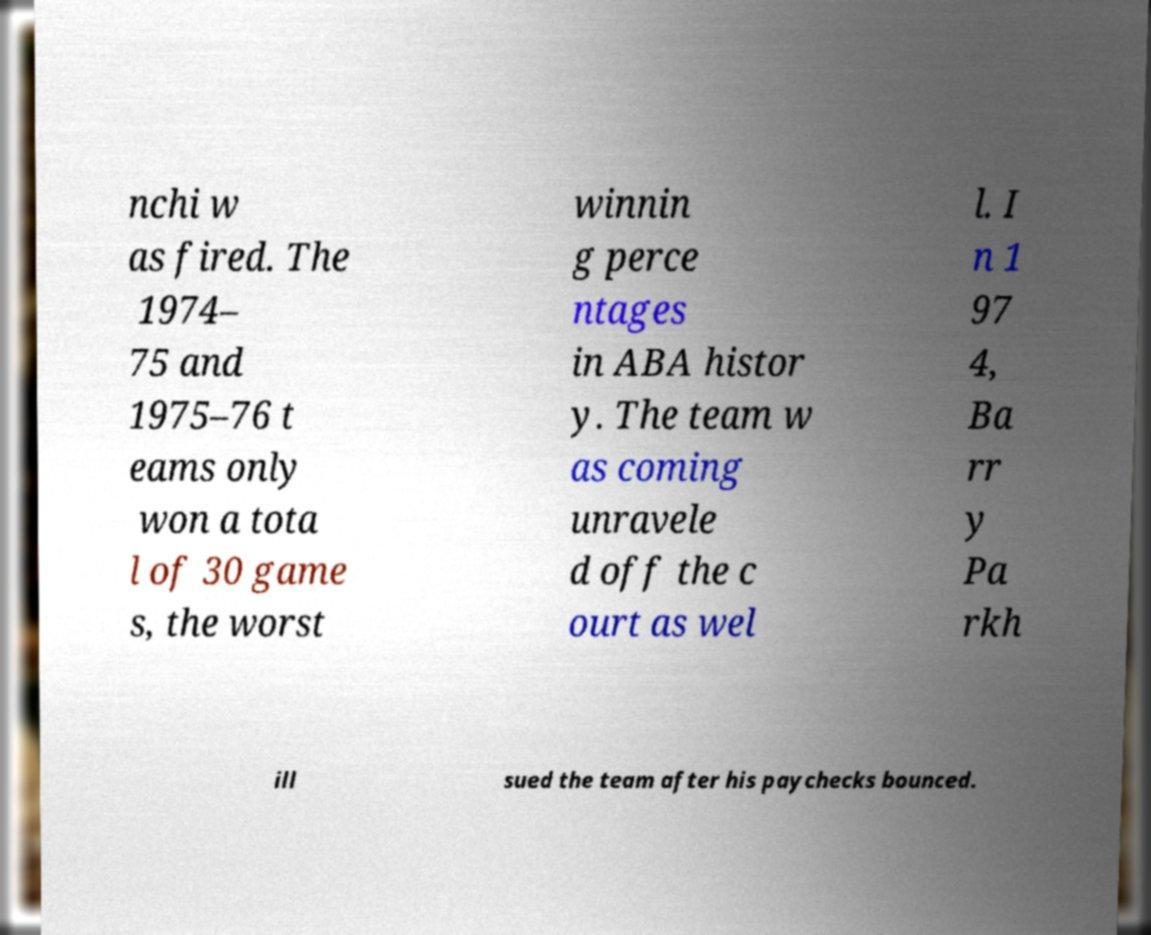For documentation purposes, I need the text within this image transcribed. Could you provide that? nchi w as fired. The 1974– 75 and 1975–76 t eams only won a tota l of 30 game s, the worst winnin g perce ntages in ABA histor y. The team w as coming unravele d off the c ourt as wel l. I n 1 97 4, Ba rr y Pa rkh ill sued the team after his paychecks bounced. 